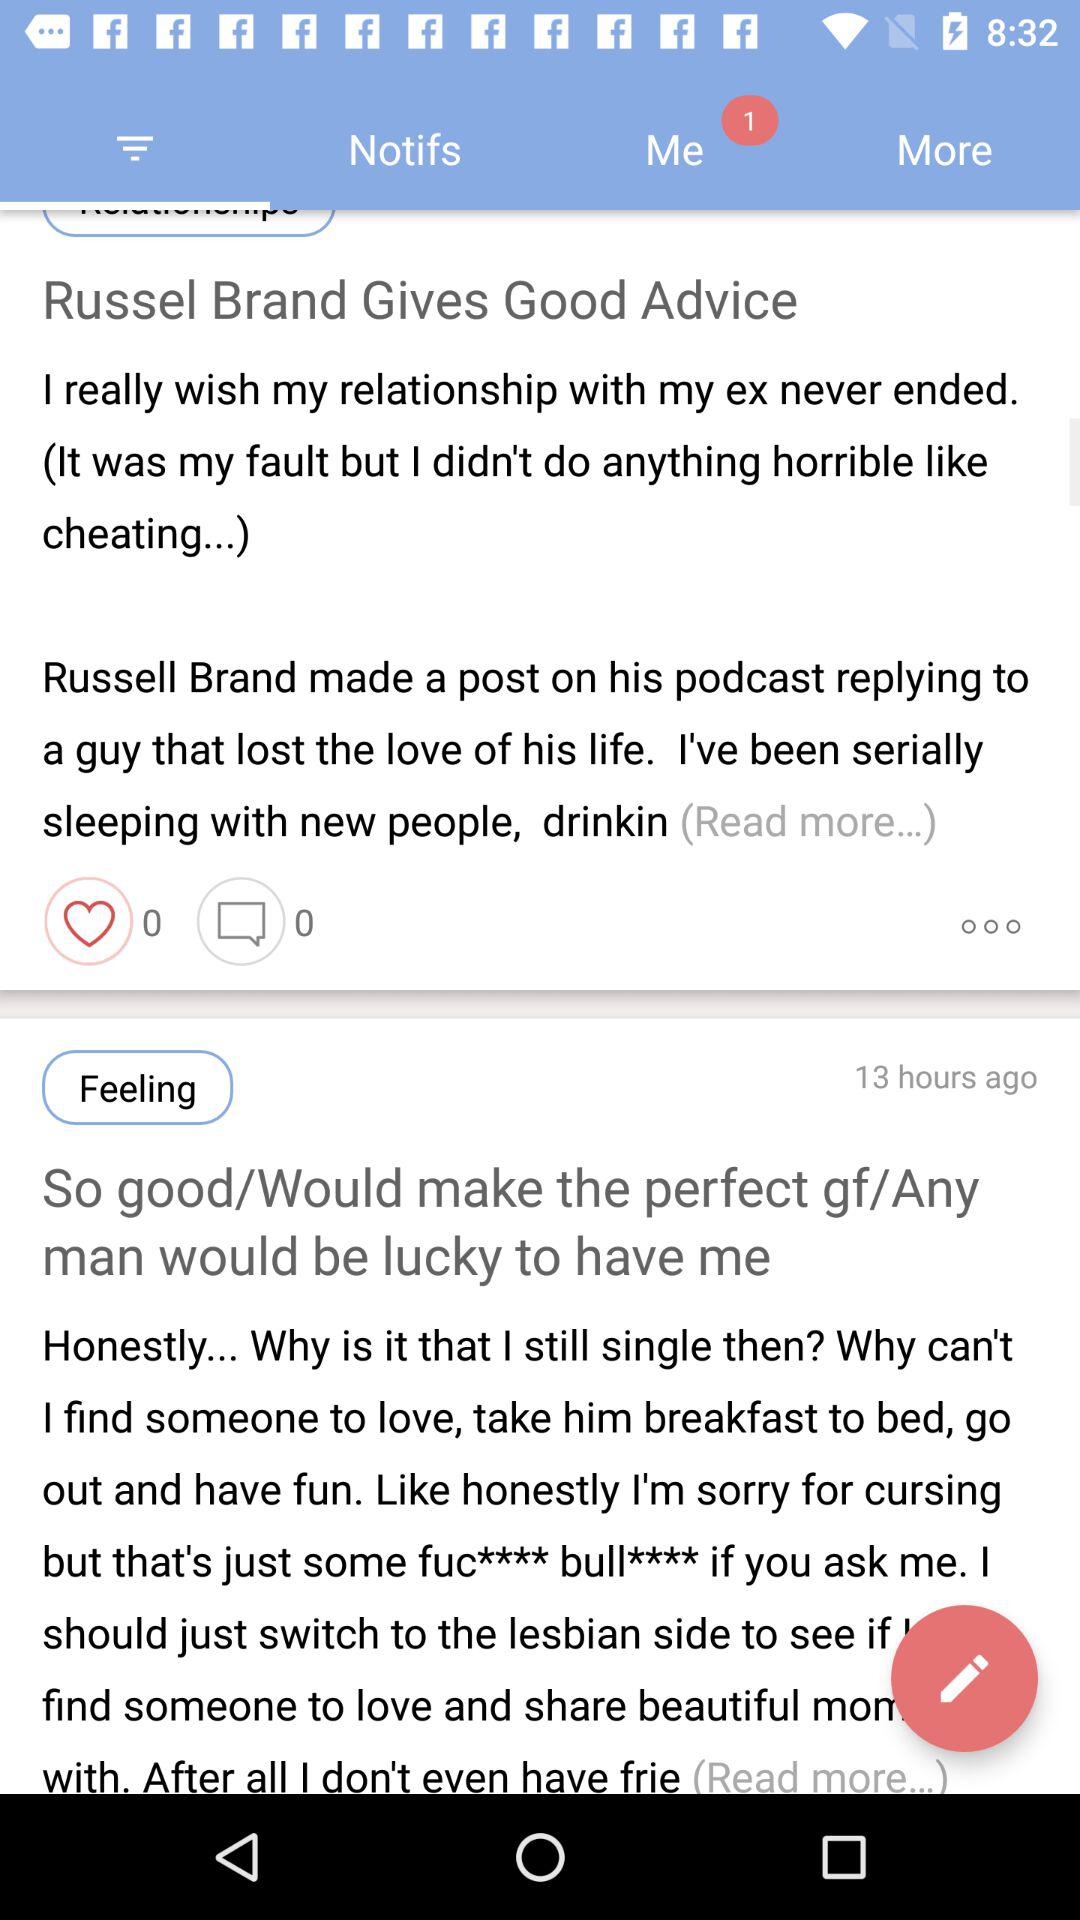How many hours ago was the second item posted?
Answer the question using a single word or phrase. 13 